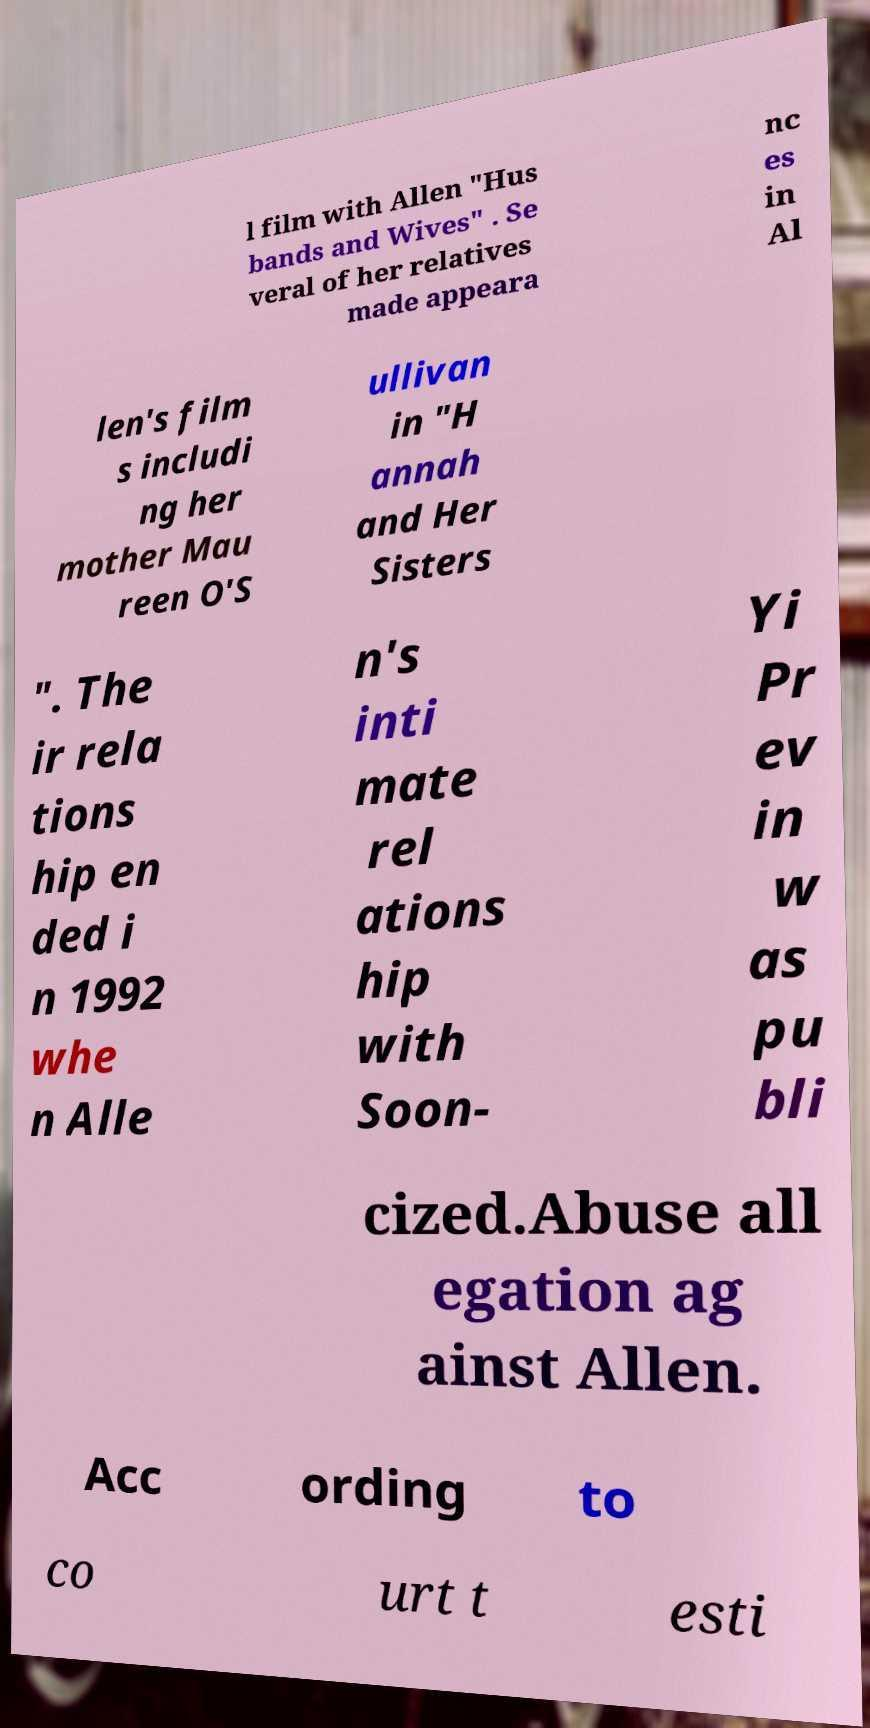What messages or text are displayed in this image? I need them in a readable, typed format. l film with Allen "Hus bands and Wives" . Se veral of her relatives made appeara nc es in Al len's film s includi ng her mother Mau reen O'S ullivan in "H annah and Her Sisters ". The ir rela tions hip en ded i n 1992 whe n Alle n's inti mate rel ations hip with Soon- Yi Pr ev in w as pu bli cized.Abuse all egation ag ainst Allen. Acc ording to co urt t esti 